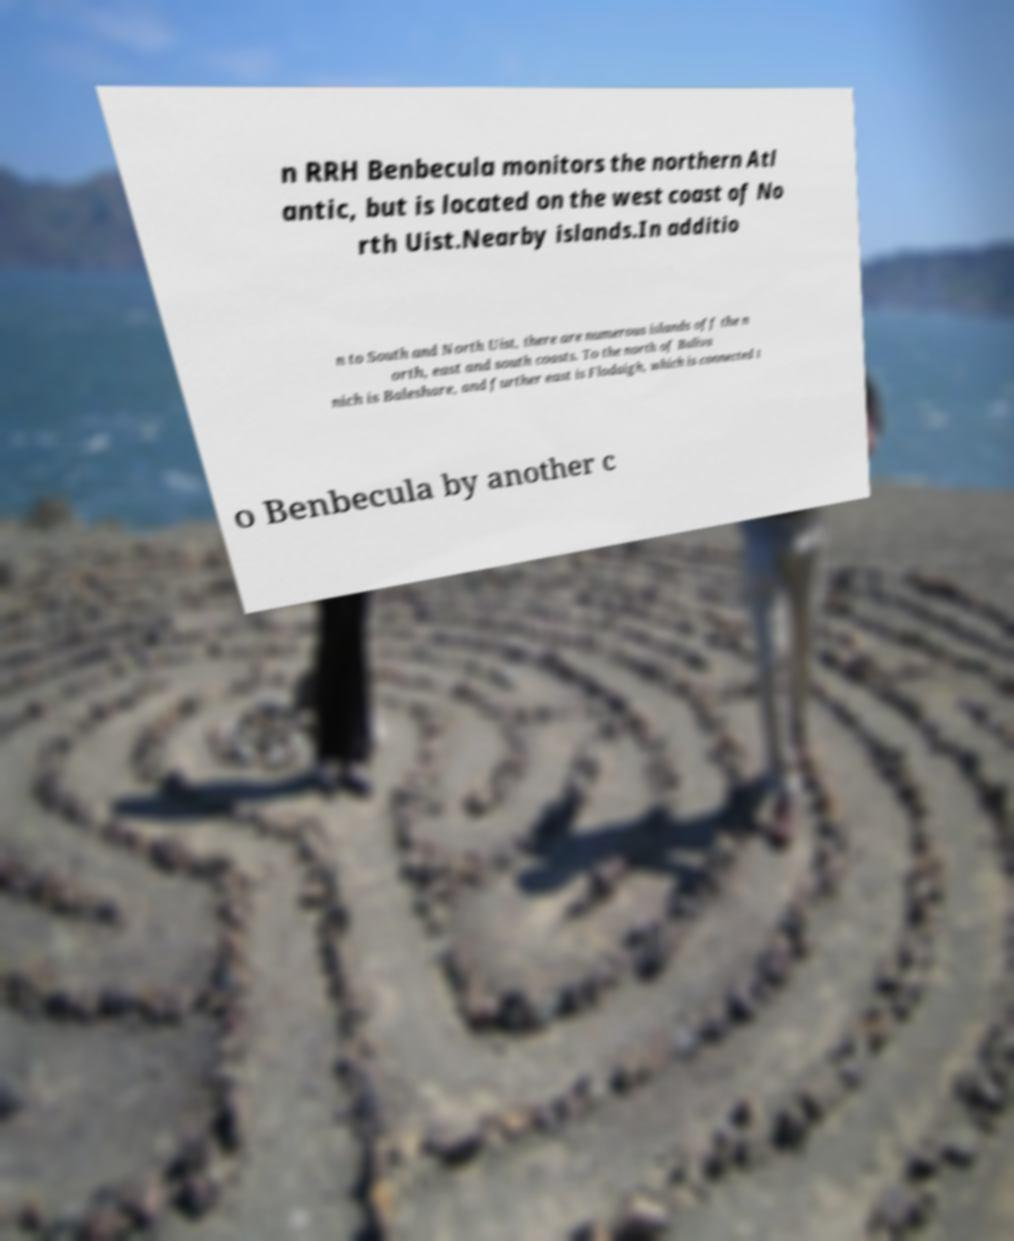What messages or text are displayed in this image? I need them in a readable, typed format. n RRH Benbecula monitors the northern Atl antic, but is located on the west coast of No rth Uist.Nearby islands.In additio n to South and North Uist, there are numerous islands off the n orth, east and south coasts. To the north of Baliva nich is Baleshare, and further east is Flodaigh, which is connected t o Benbecula by another c 